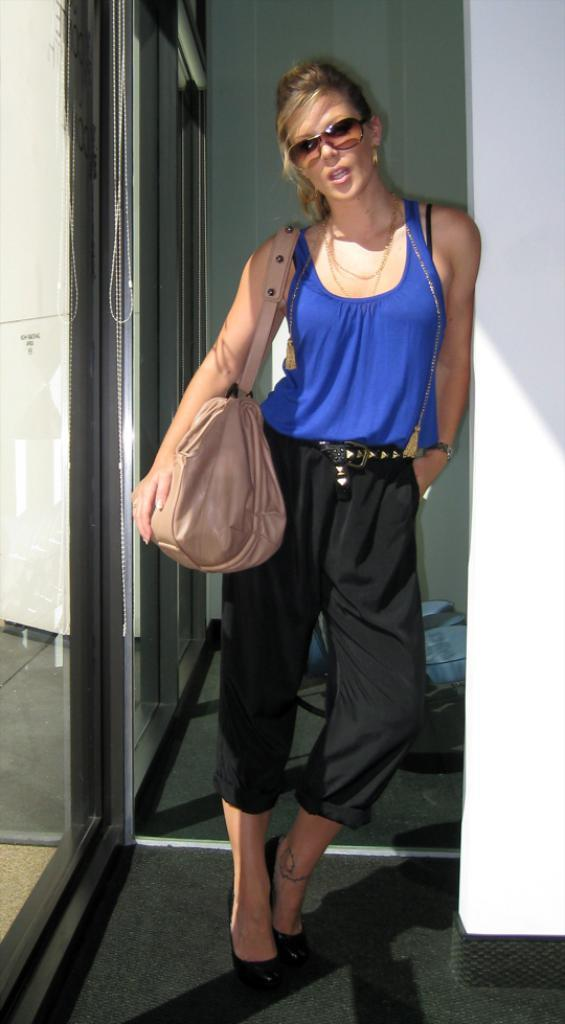What is the main subject of the image? The main subject of the image is a woman. Can you describe the woman's clothing in the image? The woman is wearing a blue T-shirt, black pants, and black heels. What accessory is the woman carrying in the image? The woman is carrying a bag in the image. Can you describe the woman's eyewear in the image? The woman is wearing spectacles in the image. What can be seen on the left side of the image? There is a glass wall on the left side of the image. What can be seen on the right side of the image? There is a white wall on the right side of the image. What type of dock can be seen in the image? There is no dock present in the image. What is the woman's eye color in the image? The image does not provide information about the woman's eye color. 